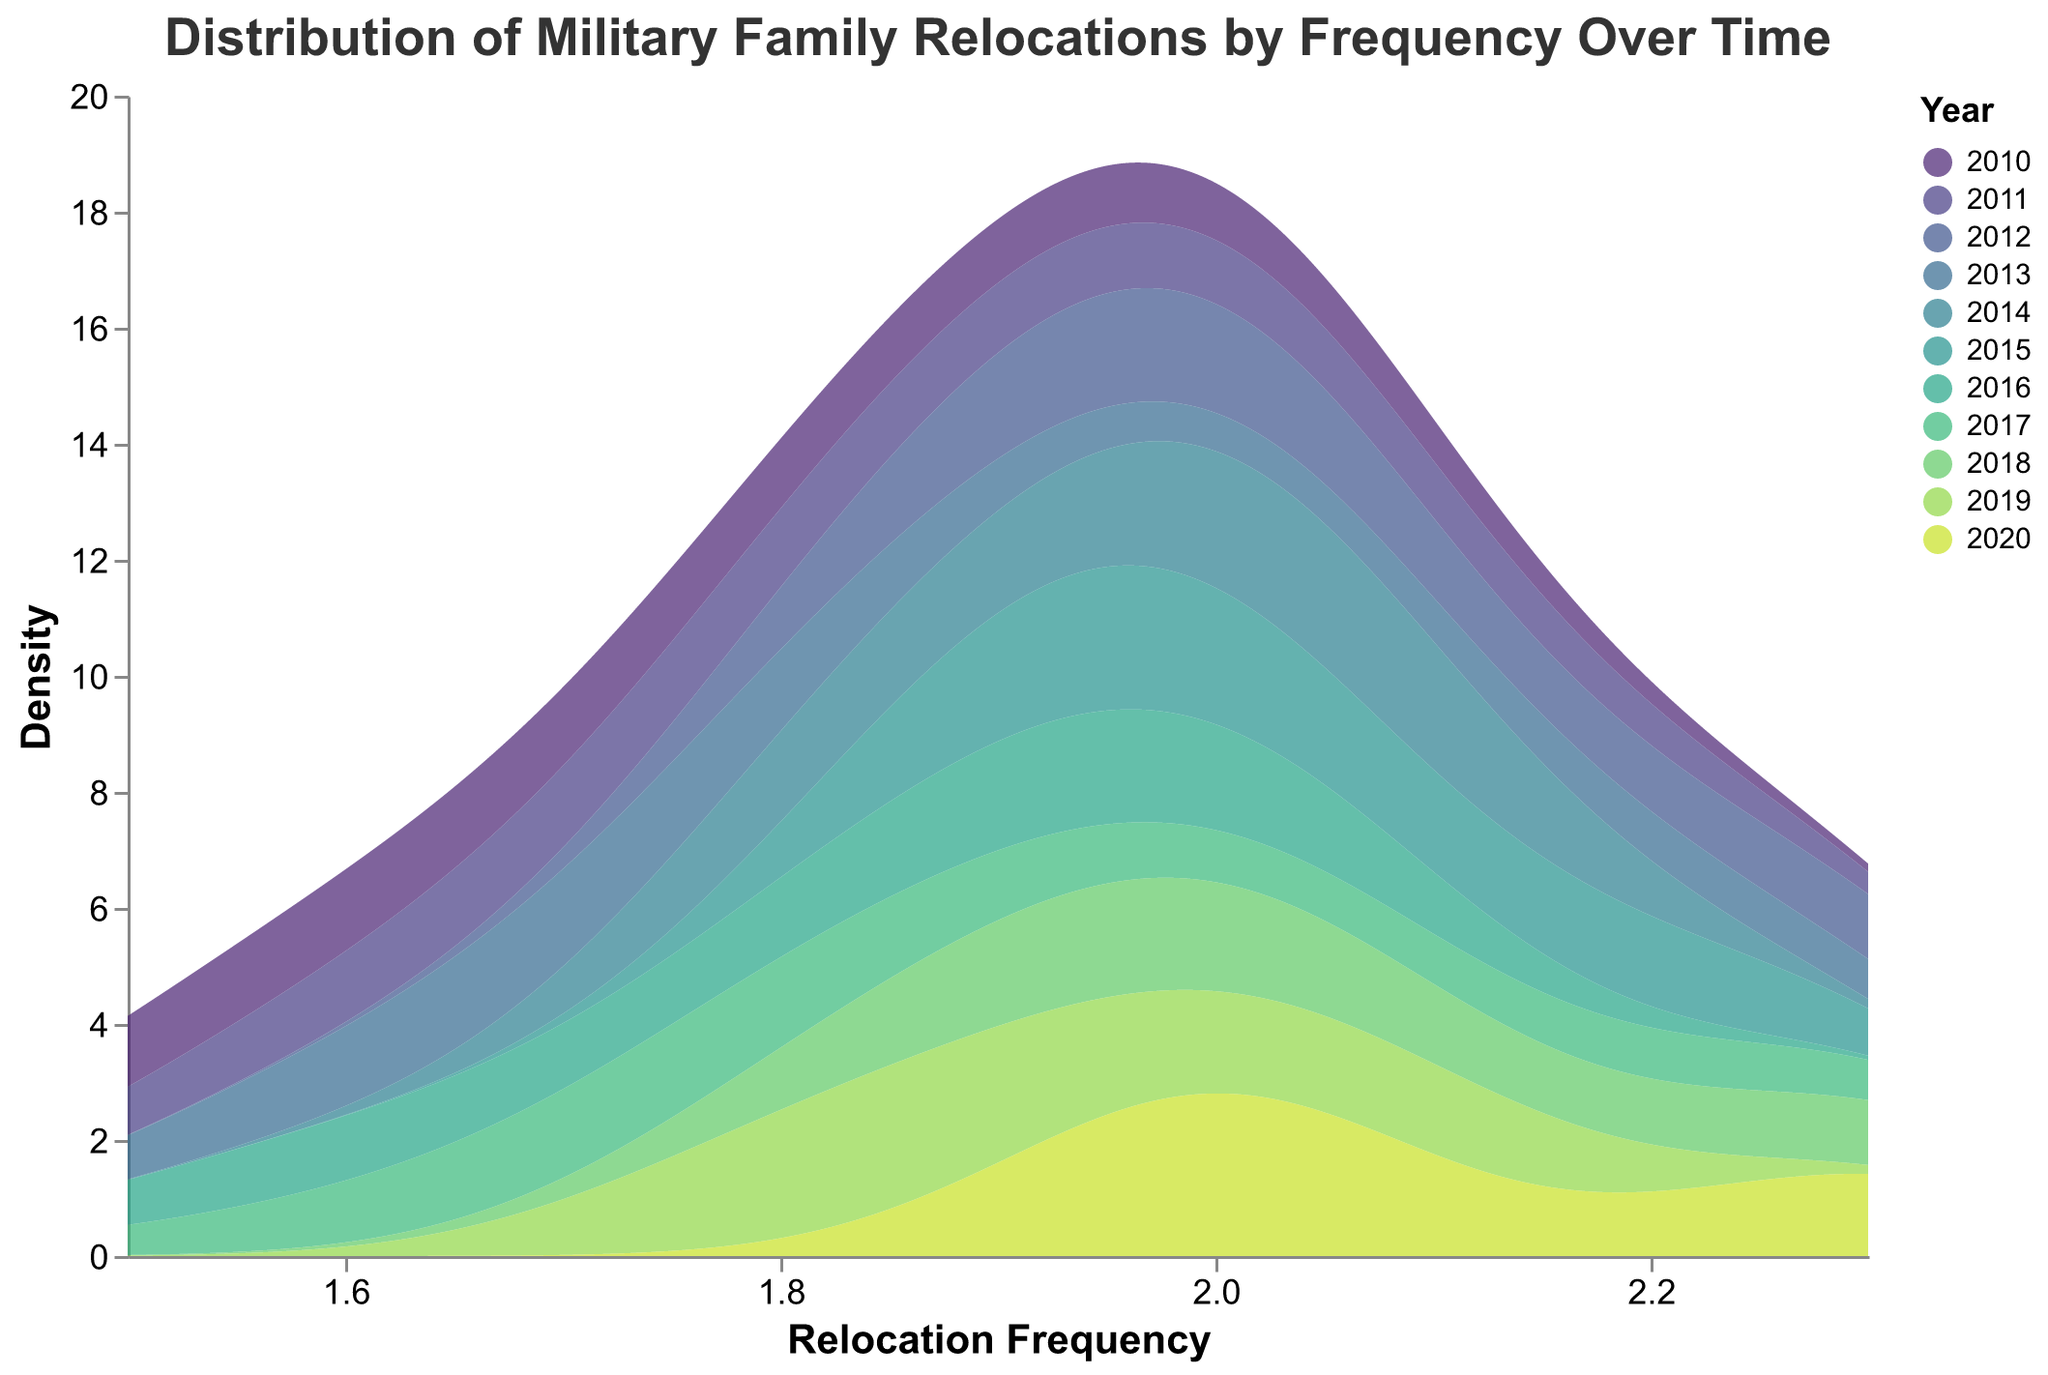What is the title of the plot? The title is typically displayed at the top of the plot and provides a summary of what the plot is about.
Answer: Distribution of Military Family Relocations by Frequency Over Time What does the x-axis represent? The x-axis typically represents the range of the data being examined, which in this case is clearly labeled under the axis in the plot.
Answer: Relocation Frequency Which year had the highest density at approximately 2.0 relocation frequency? By looking at the density peaks at the location corresponding to a relocation frequency of 2.0, you can identify the tallest peak among various years.
Answer: 2020 Is the relocation frequency generally increasing or decreasing over time? To determine this, you examine the general trend of density distributions over the years to see if they shift towards higher or lower frequencies.
Answer: Generally increasing Which year has the widest spread in relocation frequency? By observing the width of the density plots, you can determine which year's distribution covers the broadest range of relocation frequencies.
Answer: 2012 Which year has the narrowest peak in the density plot? To find the narrowest peak, observe which year's density plot has the steepest and highest peak, indicating a concentrated frequency value.
Answer: 2011 How does the density at relocation frequency 1.7 compare between 2013 and 2017? Compare the height (density) of the curves at the frequency value of 1.7 for both years.
Answer: Higher in 2013 What is the approximate range of relocation frequencies covered by the density plots? The range is observed by noting the minimum and maximum values on the x-axis across all density plots.
Answer: 1.5 to 2.3 Which years had a peak density at a relocation frequency of 2.3? Identify the years whose density plots have a local maximum near the frequency value of 2.3.
Answer: 2012, 2018, 2020 What could be a reason for the different shapes of density plots over the years? Understanding the variability in density plots suggests considering factors like changing military policies, global events, or economic conditions affecting relocations.
Answer: Policy changes and global events 